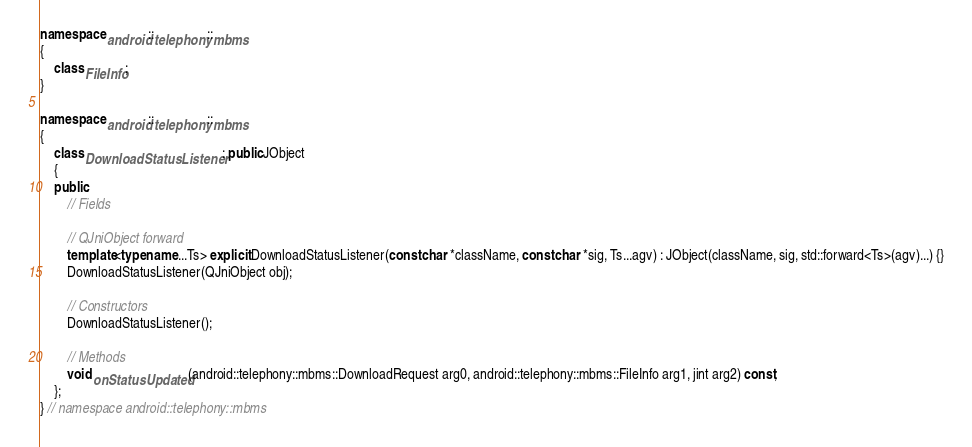<code> <loc_0><loc_0><loc_500><loc_500><_C++_>namespace android::telephony::mbms
{
	class FileInfo;
}

namespace android::telephony::mbms
{
	class DownloadStatusListener : public JObject
	{
	public:
		// Fields
		
		// QJniObject forward
		template<typename ...Ts> explicit DownloadStatusListener(const char *className, const char *sig, Ts...agv) : JObject(className, sig, std::forward<Ts>(agv)...) {}
		DownloadStatusListener(QJniObject obj);
		
		// Constructors
		DownloadStatusListener();
		
		// Methods
		void onStatusUpdated(android::telephony::mbms::DownloadRequest arg0, android::telephony::mbms::FileInfo arg1, jint arg2) const;
	};
} // namespace android::telephony::mbms

</code> 